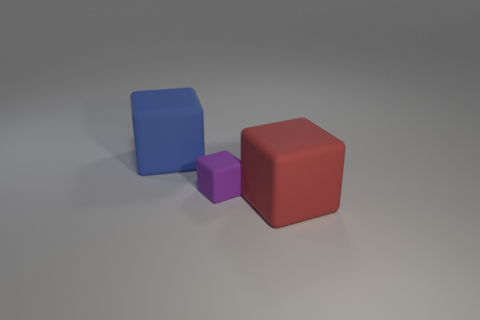Are there an equal number of big blue blocks in front of the big blue rubber object and small purple blocks that are to the right of the big red rubber object?
Provide a short and direct response. Yes. There is another thing that is the same size as the blue thing; what shape is it?
Your answer should be very brief. Cube. Is there a big object of the same color as the small object?
Make the answer very short. No. What is the shape of the large object that is behind the large red rubber thing?
Give a very brief answer. Cube. What is the color of the tiny thing?
Ensure brevity in your answer.  Purple. There is a small cube that is made of the same material as the red thing; what is its color?
Your answer should be compact. Purple. How many brown cylinders are the same material as the small purple thing?
Give a very brief answer. 0. There is a purple rubber block; how many objects are on the right side of it?
Provide a short and direct response. 1. Do the big block that is behind the red matte thing and the object in front of the small purple rubber block have the same material?
Give a very brief answer. Yes. Are there more red objects that are to the right of the red matte thing than big red blocks behind the small rubber thing?
Give a very brief answer. No. 